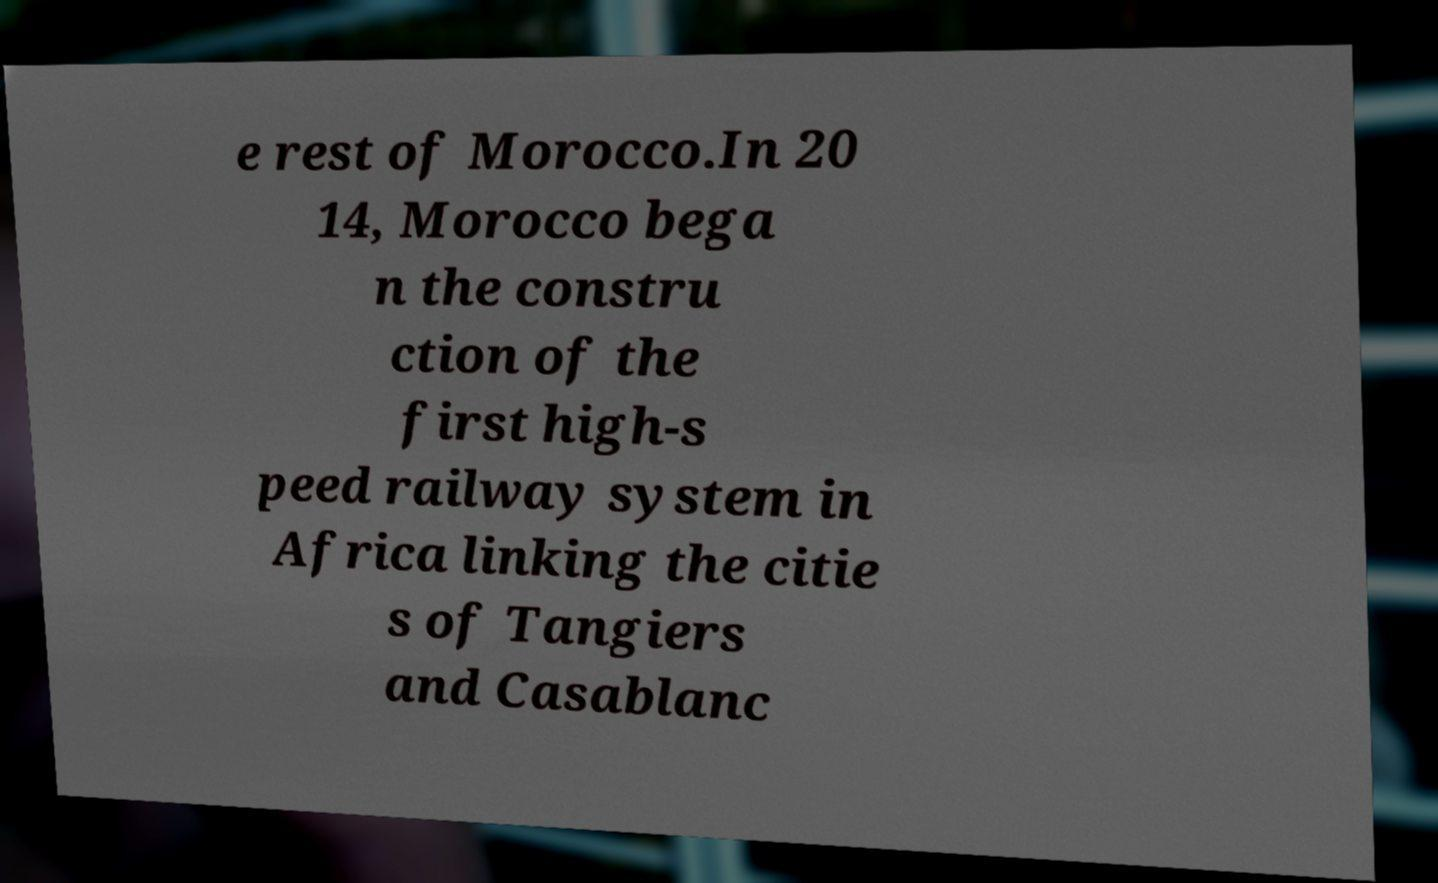What messages or text are displayed in this image? I need them in a readable, typed format. e rest of Morocco.In 20 14, Morocco bega n the constru ction of the first high-s peed railway system in Africa linking the citie s of Tangiers and Casablanc 